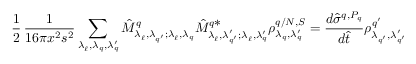<formula> <loc_0><loc_0><loc_500><loc_500>{ \frac { 1 } { 2 } } \, \frac { 1 } { 1 6 \pi x ^ { 2 } s ^ { 2 } } \sum _ { \lambda _ { \ell } ^ { \, } , \lambda _ { q } ^ { \, } , \lambda _ { q } ^ { \prime } } \hat { M } _ { \lambda _ { \ell } ^ { \, } , \lambda _ { q ^ { \prime } } ^ { \, } ; \lambda _ { \ell } ^ { \, } , \lambda _ { q } ^ { \, } } ^ { q } \hat { M } _ { \lambda _ { \ell } ^ { \, } , \lambda _ { q ^ { \prime } } ^ { \prime } ; \lambda _ { \ell } ^ { \, } , \lambda _ { q } ^ { \prime } } ^ { q * } \rho _ { \lambda _ { q } ^ { \, } , \lambda _ { q } ^ { \prime } } ^ { q / N , S } = \frac { d \hat { \sigma } ^ { q , P _ { q } } } { d \hat { t } } \rho _ { \lambda _ { q ^ { \prime } } ^ { \, } , \lambda _ { q ^ { \prime } } ^ { \prime } } ^ { q ^ { \prime } }</formula> 